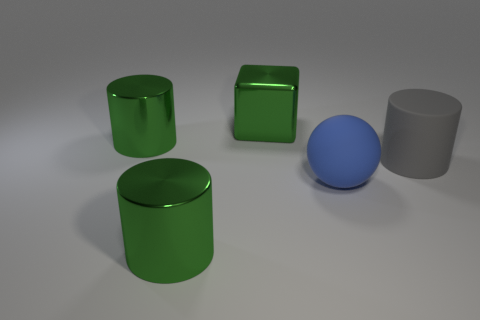Does the large shiny block have the same color as the sphere?
Your answer should be very brief. No. What number of big cylinders are made of the same material as the ball?
Provide a succinct answer. 1. Are the big thing on the right side of the ball and the large cube made of the same material?
Make the answer very short. No. Are there the same number of big balls that are behind the blue matte object and big green shiny things?
Provide a short and direct response. No. What size is the blue object?
Ensure brevity in your answer.  Large. How many other matte spheres are the same color as the big ball?
Offer a very short reply. 0. Is the size of the green metallic block the same as the blue object?
Keep it short and to the point. Yes. How big is the shiny object that is in front of the big metallic cylinder behind the blue thing?
Your answer should be compact. Large. Do the big ball and the shiny object in front of the large gray matte cylinder have the same color?
Offer a very short reply. No. Are there any purple cylinders that have the same size as the gray object?
Keep it short and to the point. No. 